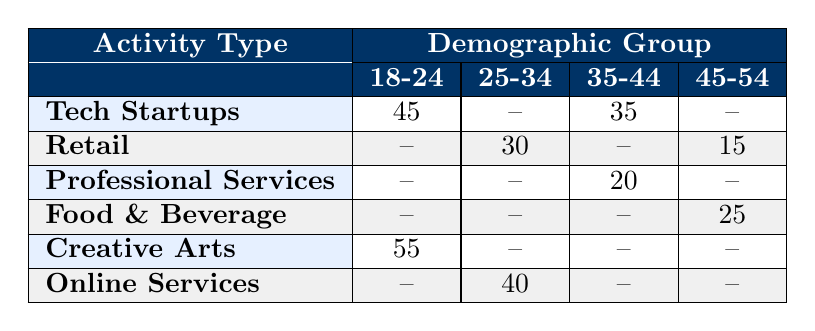What is the usage frequency of Tech Startups for the 18-24 demographic group? From the table, the usage frequency for Tech Startups in the 18-24 demographic is given directly as 45.
Answer: 45 What is the usage frequency for Creative Arts in the 25-34 demographic group? The table indicates that there is no recorded usage frequency for Creative Arts in the 25-34 demographic, shown as "--".
Answer: No Which entrepreneurial activity type has the highest usage frequency for the 45-54 demographic group? By looking at the 45-54 row, Food & Beverage has a usage frequency of 25, while Retail has a usage frequency of 15. Therefore, Food & Beverage is the highest at 25.
Answer: Food & Beverage Is there any entrepreneurial activity type that has no recorded usage for the 18-24 demographic group? Checking the 18-24 column, Professional Services and Retail show no recorded usage frequencies, indicated by "--". Thus, it is true that these types have no recorded usage.
Answer: Yes What is the sum of the usage frequencies for the 25-34 demographic group? In the 25-34 column, Retail shows 30 and Online Services shows 40. Adding these values together gives us 30 + 40 = 70.
Answer: 70 Which demographic group shows the highest combined usage frequency across all entrepreneurial activities? To find the highest combined usage, we look at each row for frequency values: 18-24 totals up to 100 (45 + 55), 25-34 totals 70 (30 + 40), 35-44 totals 55 (35 + 20), and 45-54 totals 40 (25 + 15). The highest total is for the 18-24 group.
Answer: 18-24 What is the difference in usage frequency between Tech Startups for the 18-24 and 35-44 demographic groups? The usage frequency for Tech Startups in the 18-24 demographic is 45, and in the 35-44 demographic it is 35. The difference is 45 - 35 = 10.
Answer: 10 Does the table show that Retail usage frequency is higher among the 25-34 or 45-54 demographic groups? The usage frequency for Retail in the 25-34 demographic is 30, while in the 45-54 demographic it is 15. Thus, Retail has a higher frequency among the 25-34 group.
Answer: Yes 